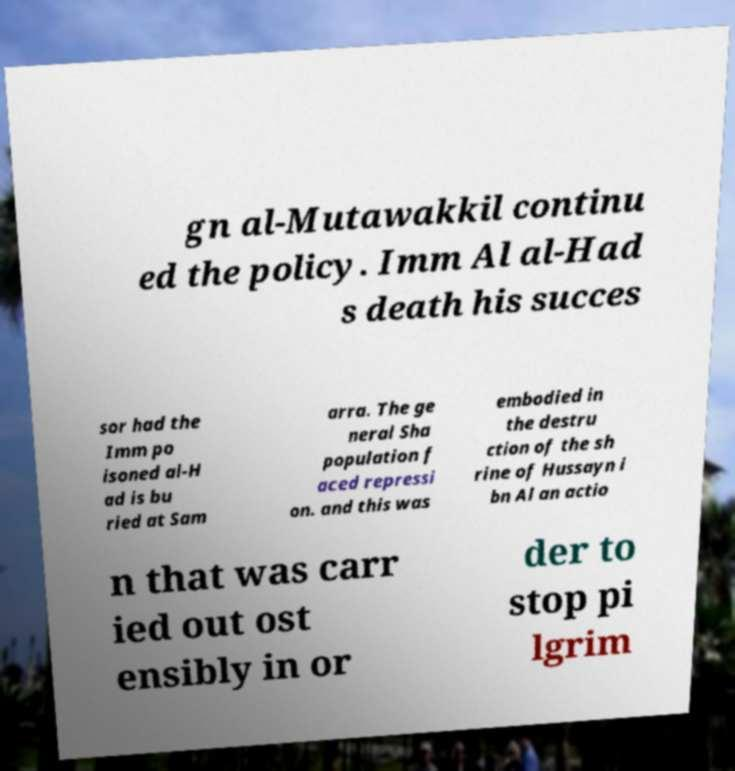Can you read and provide the text displayed in the image?This photo seems to have some interesting text. Can you extract and type it out for me? gn al-Mutawakkil continu ed the policy. Imm Al al-Had s death his succes sor had the Imm po isoned al-H ad is bu ried at Sam arra. The ge neral Sha population f aced repressi on. and this was embodied in the destru ction of the sh rine of Hussayn i bn Al an actio n that was carr ied out ost ensibly in or der to stop pi lgrim 